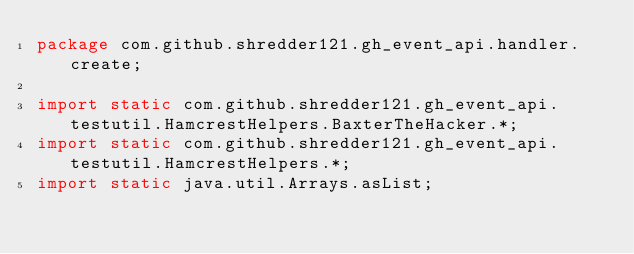<code> <loc_0><loc_0><loc_500><loc_500><_Java_>package com.github.shredder121.gh_event_api.handler.create;

import static com.github.shredder121.gh_event_api.testutil.HamcrestHelpers.BaxterTheHacker.*;
import static com.github.shredder121.gh_event_api.testutil.HamcrestHelpers.*;
import static java.util.Arrays.asList;</code> 